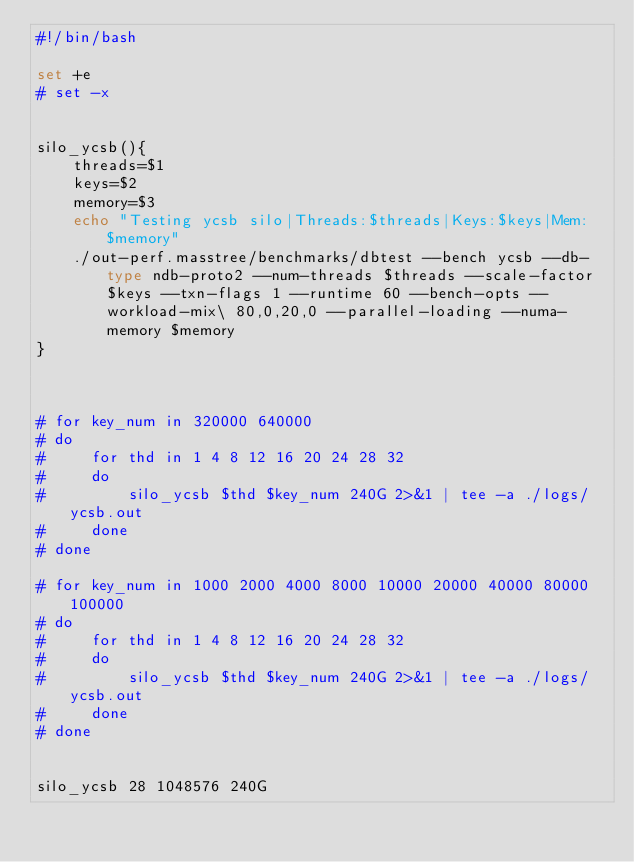Convert code to text. <code><loc_0><loc_0><loc_500><loc_500><_Bash_>#!/bin/bash

set +e
# set -x


silo_ycsb(){
    threads=$1
    keys=$2
    memory=$3
    echo "Testing ycsb silo|Threads:$threads|Keys:$keys|Mem:$memory"
    ./out-perf.masstree/benchmarks/dbtest --bench ycsb --db-type ndb-proto2 --num-threads $threads --scale-factor $keys --txn-flags 1 --runtime 60 --bench-opts --workload-mix\ 80,0,20,0 --parallel-loading --numa-memory $memory
}



# for key_num in 320000 640000
# do
#     for thd in 1 4 8 12 16 20 24 28 32
#     do
#         silo_ycsb $thd $key_num 240G 2>&1 | tee -a ./logs/ycsb.out
#     done
# done

# for key_num in 1000 2000 4000 8000 10000 20000 40000 80000 100000
# do
#     for thd in 1 4 8 12 16 20 24 28 32
#     do
#         silo_ycsb $thd $key_num 240G 2>&1 | tee -a ./logs/ycsb.out
#     done
# done


silo_ycsb 28 1048576 240G</code> 